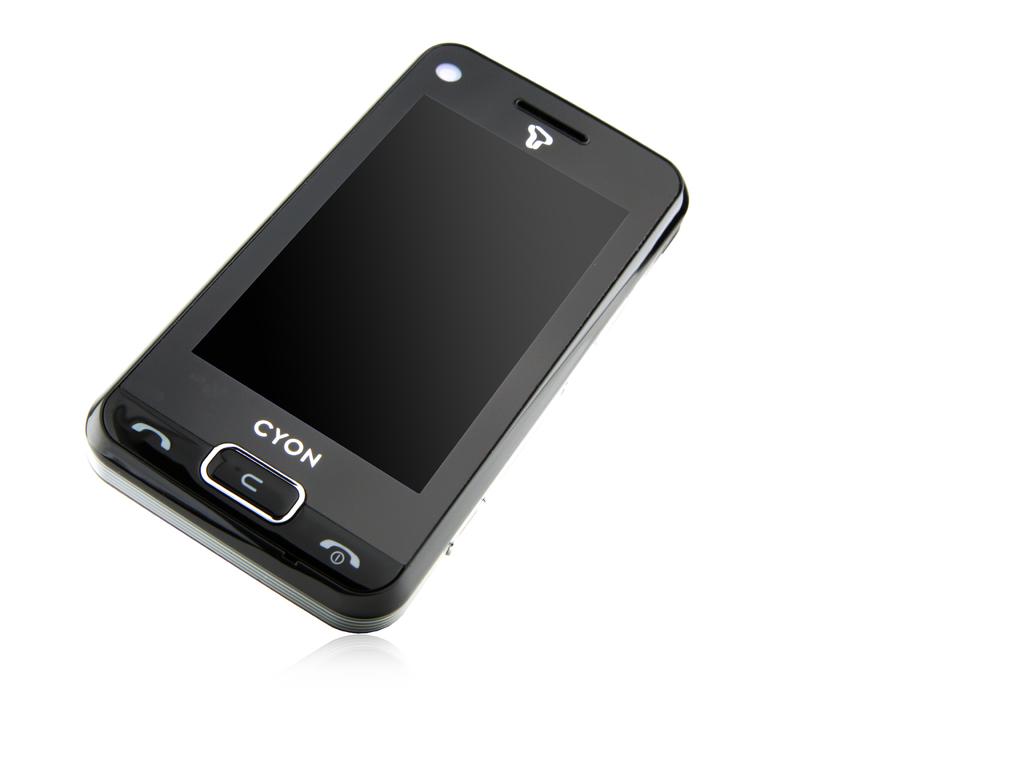What is the brand of this device?
Give a very brief answer. Cyon. 